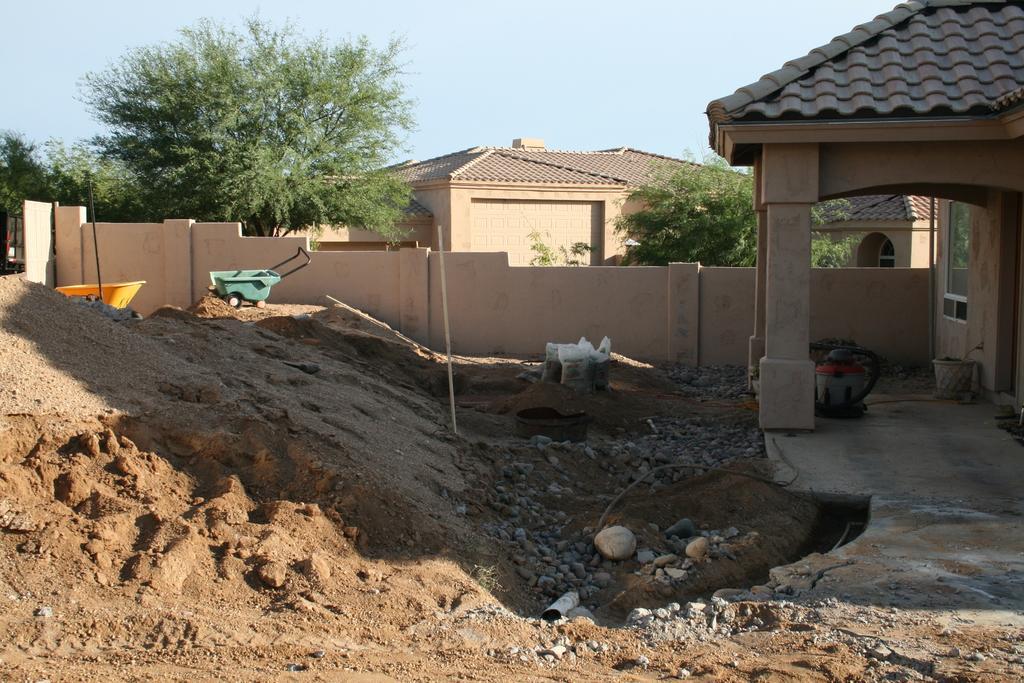Can you describe this image briefly? In the picture we can see the sand and beside it, we can see some stones on the surface and near it, we can see the part of the house with pillars and behind it, we can see the wall and near it, we can see two carts and behind the wall we can see the tree and some plant and we can also see some house and in the background we can see the sky. 